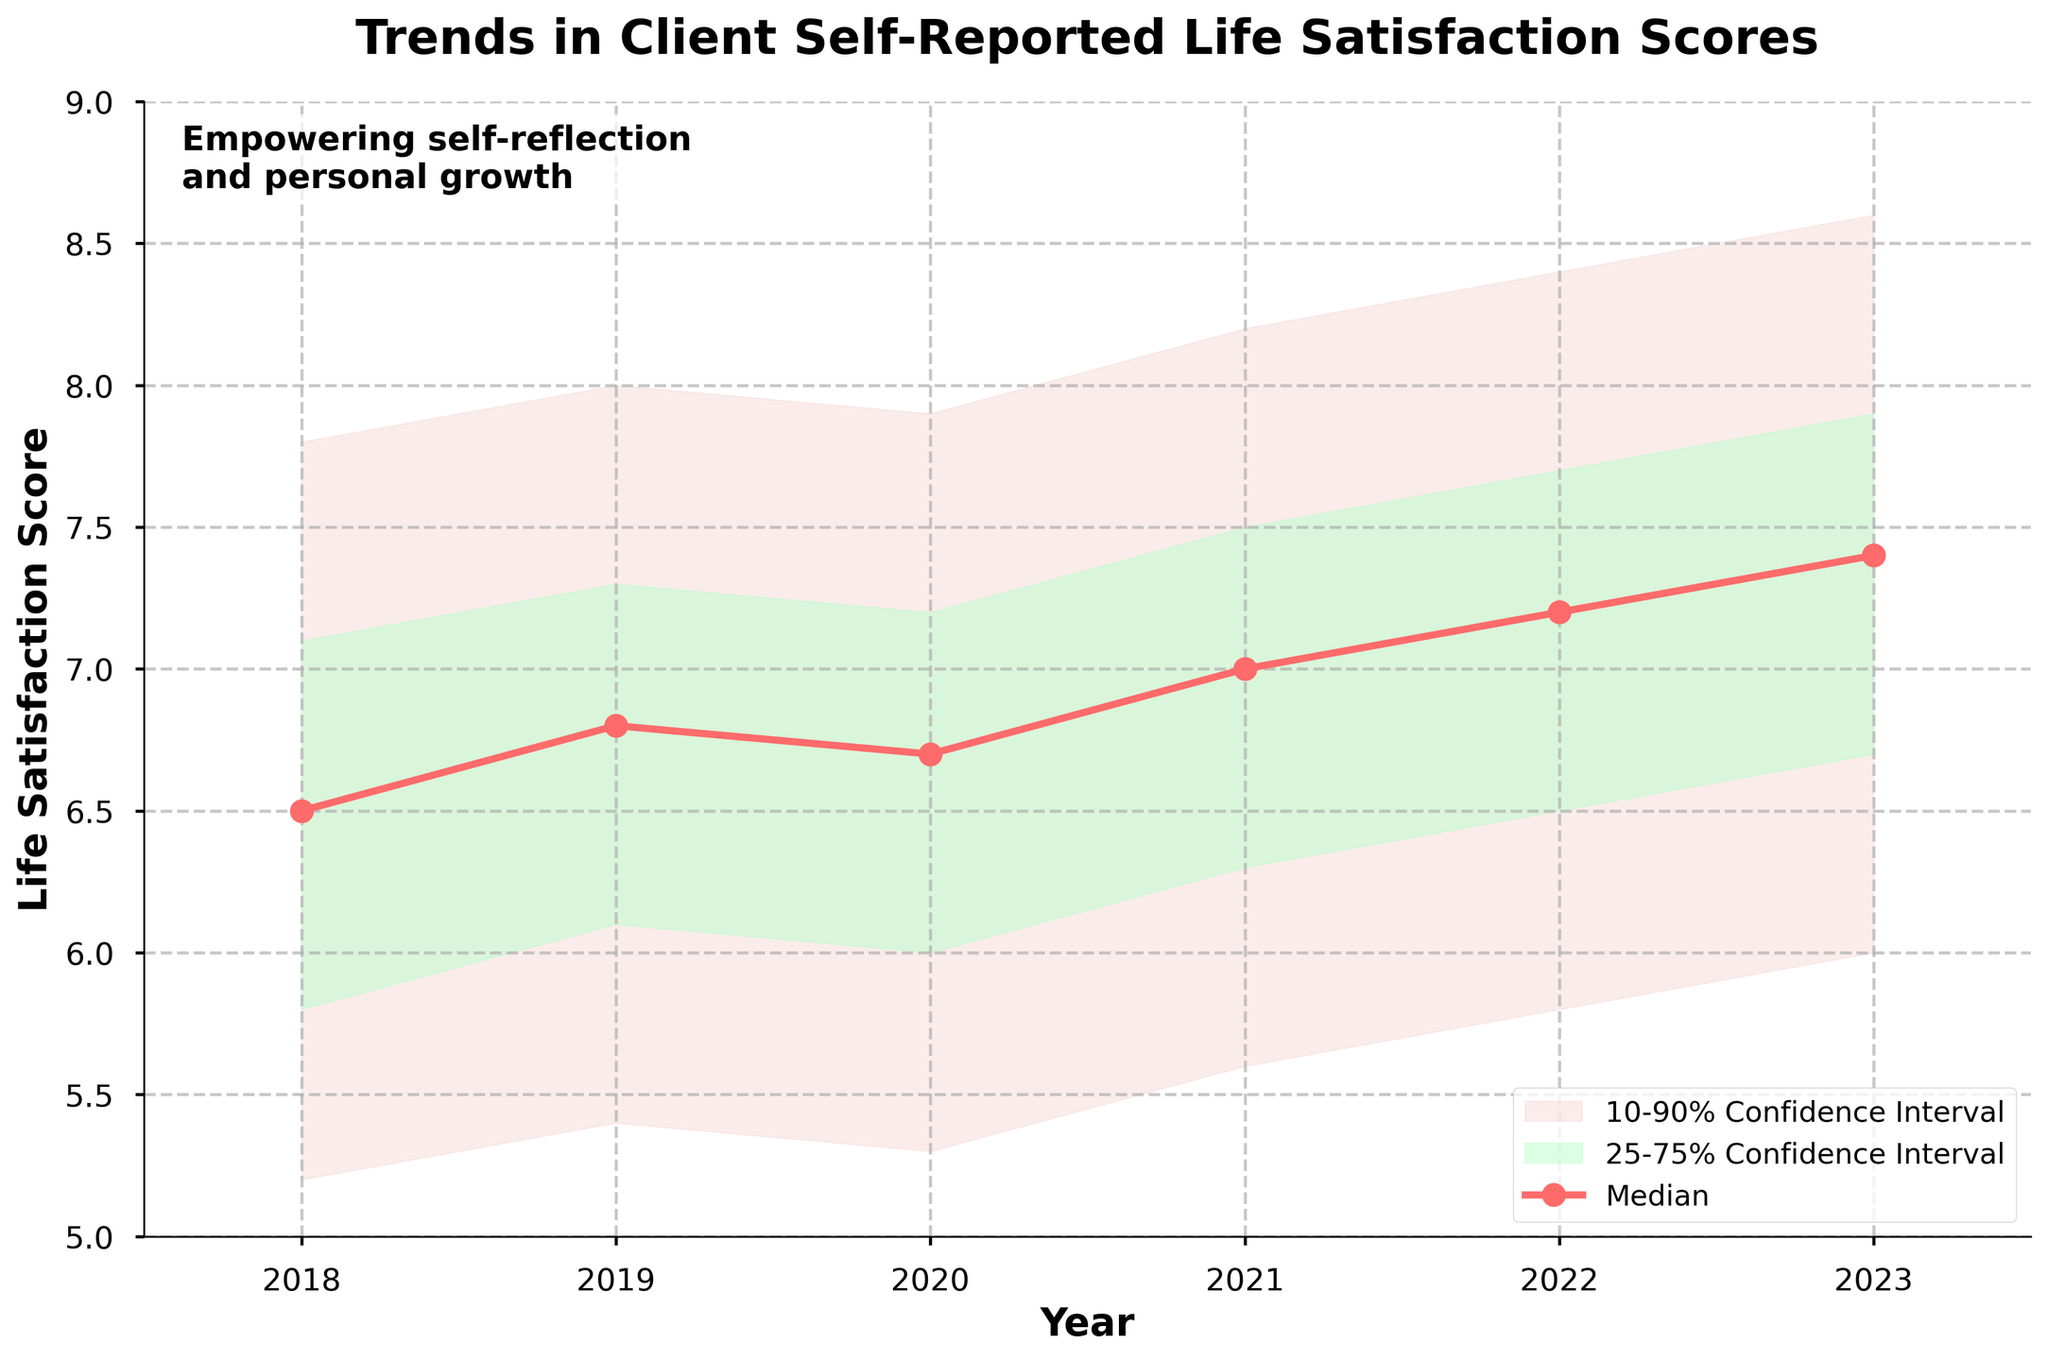What's the title of the chart? The title of the chart is located at the top of the figure and provides a brief summary of the data presented.
Answer: Trends in Client Self-Reported Life Satisfaction Scores How many years of data are presented in the chart? By looking at the x-axis, the range of years presented is visible.
Answer: 6 What is the median life satisfaction score in 2021? The median life satisfaction score is represented by the red line with circular markers. Find the point corresponding to 2021.
Answer: 7.0 In which year did the median life satisfaction score show the greatest increase compared to the previous year? Calculate the differences in the median values between consecutive years and determine the year with the largest positive difference.
Answer: 2023 Are clients more confident about their life satisfaction scores in 2020 or 2023? Compare the width of the confidence intervals (shaded areas) in 2020 and 2023; narrower intervals indicate higher confidence.
Answer: 2023 What is the range of life satisfaction scores between the 10th and 90th percentiles in 2022? Identify the lower bound of the 10th percentile and the upper bound of the 90th percentile for 2022, then calculate the difference.
Answer: 2.6 Which year had the narrowest 25-75% confidence interval? Compare the widths of the darker shaded areas (25-75% interval) across all years to find the narrowest one.
Answer: 2019 Did the life satisfaction scores generally improve or decline over the years shown? Look at the trend of the median values over the years to determine the overall direction of change.
Answer: Improve What does the shaded area between the lower 25% and upper 75% represent on this chart? The shaded area shows the interquartile range, representing where the middle 50% of the data points lie.
Answer: 25-75% Confidence Interval How does the life satisfaction score in 2019's upper 75th percentile compare to the 2021 median score? Find the upper 75th percentile value for 2019 and the median value for 2021, then compare them.
Answer: Equal (7.3) 